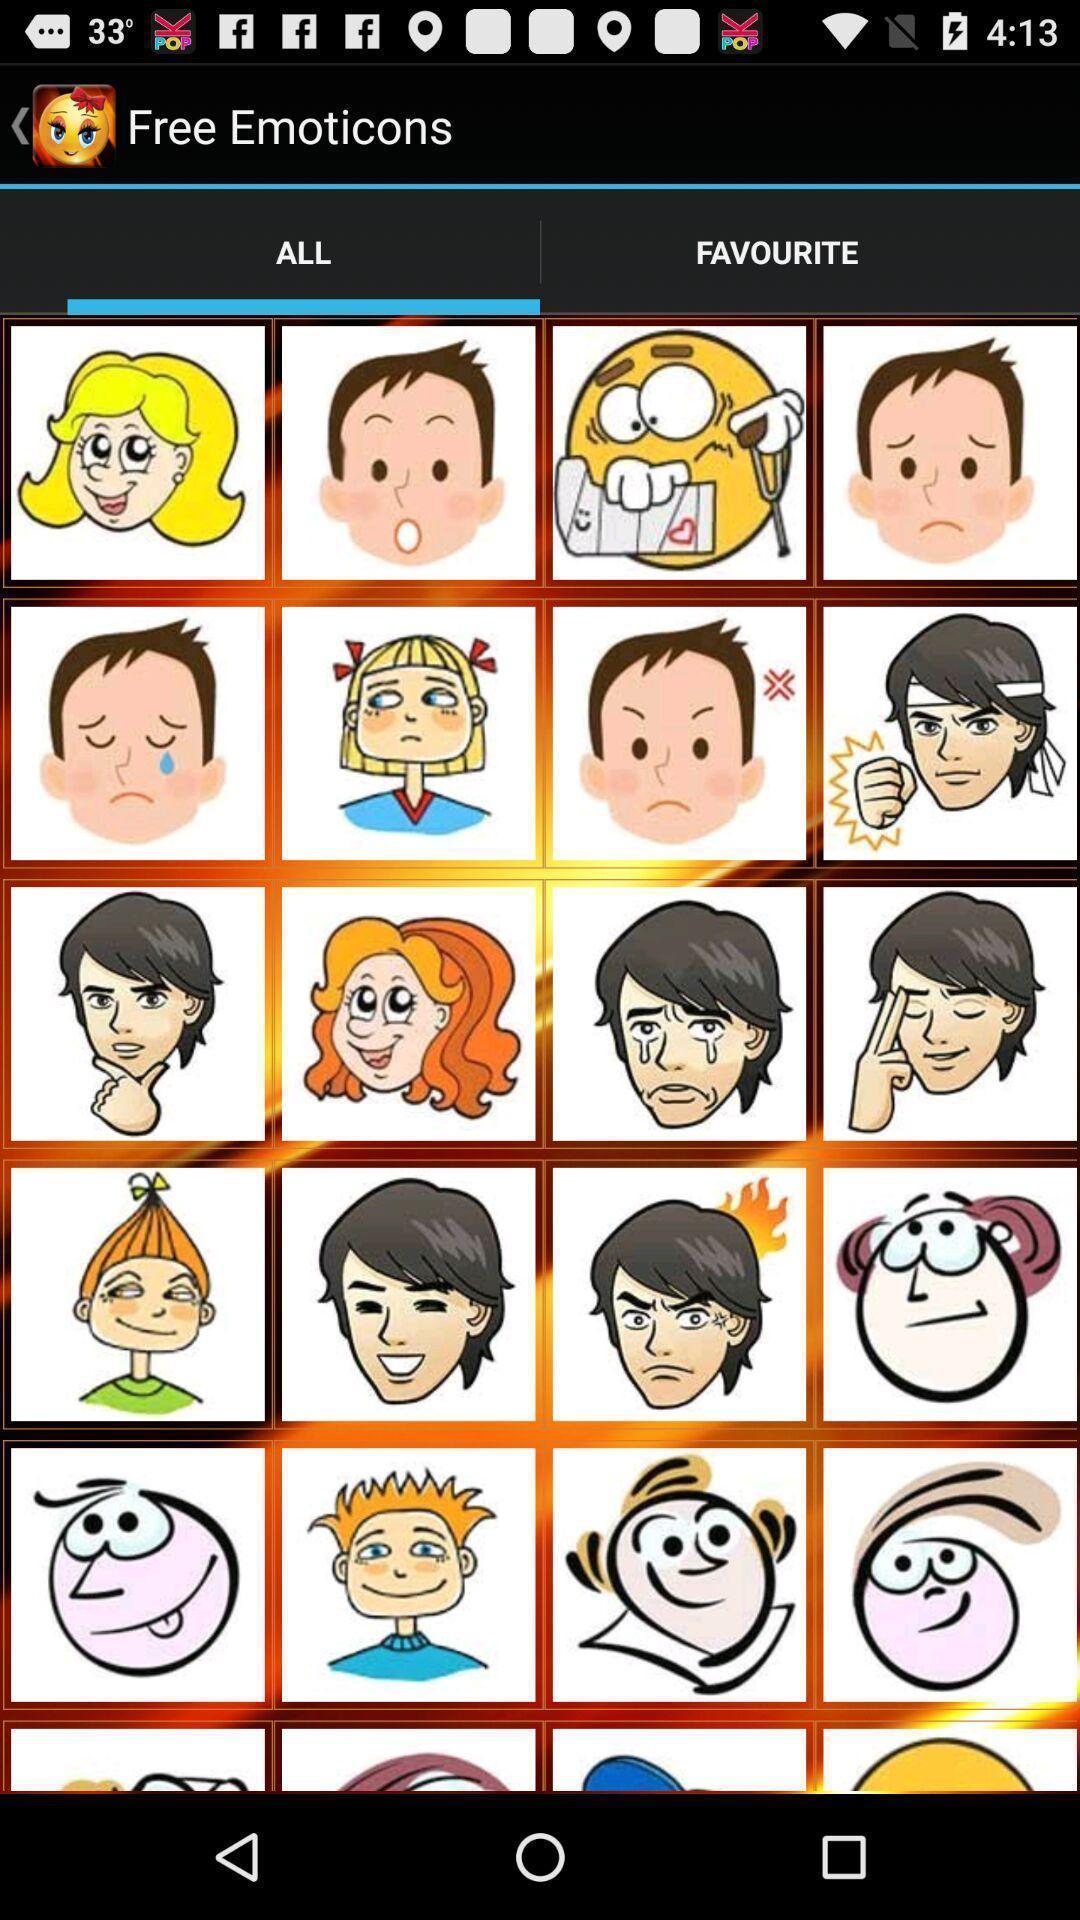Tell me what you see in this picture. Screen showing stickers. 